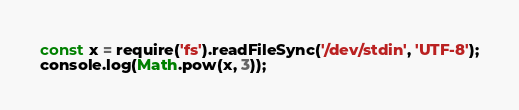Convert code to text. <code><loc_0><loc_0><loc_500><loc_500><_JavaScript_>const x = require('fs').readFileSync('/dev/stdin', 'UTF-8');
console.log(Math.pow(x, 3));

</code> 